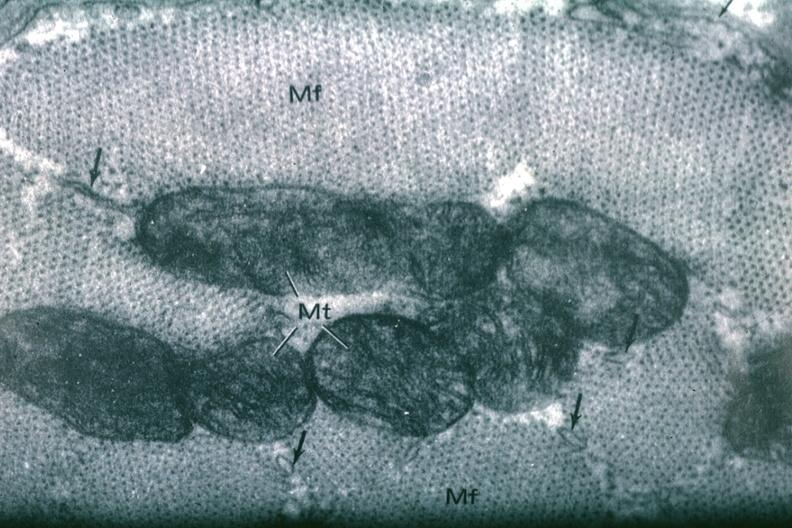s cardiovascular present?
Answer the question using a single word or phrase. Yes 